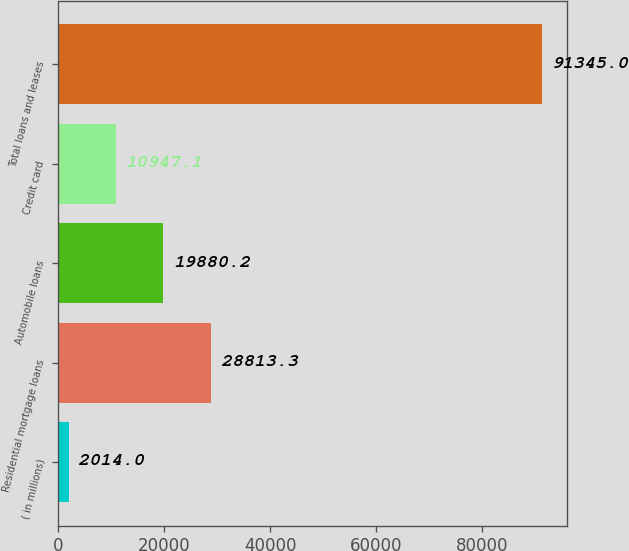Convert chart to OTSL. <chart><loc_0><loc_0><loc_500><loc_500><bar_chart><fcel>( in millions)<fcel>Residential mortgage loans<fcel>Automobile loans<fcel>Credit card<fcel>Total loans and leases<nl><fcel>2014<fcel>28813.3<fcel>19880.2<fcel>10947.1<fcel>91345<nl></chart> 